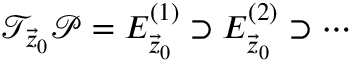<formula> <loc_0><loc_0><loc_500><loc_500>\mathcal { T } _ { \vec { z } _ { 0 } } \mathcal { P } = E _ { \vec { z } _ { 0 } } ^ { ( 1 ) } \supset E _ { \vec { z } _ { 0 } } ^ { ( 2 ) } \supset \cdots</formula> 